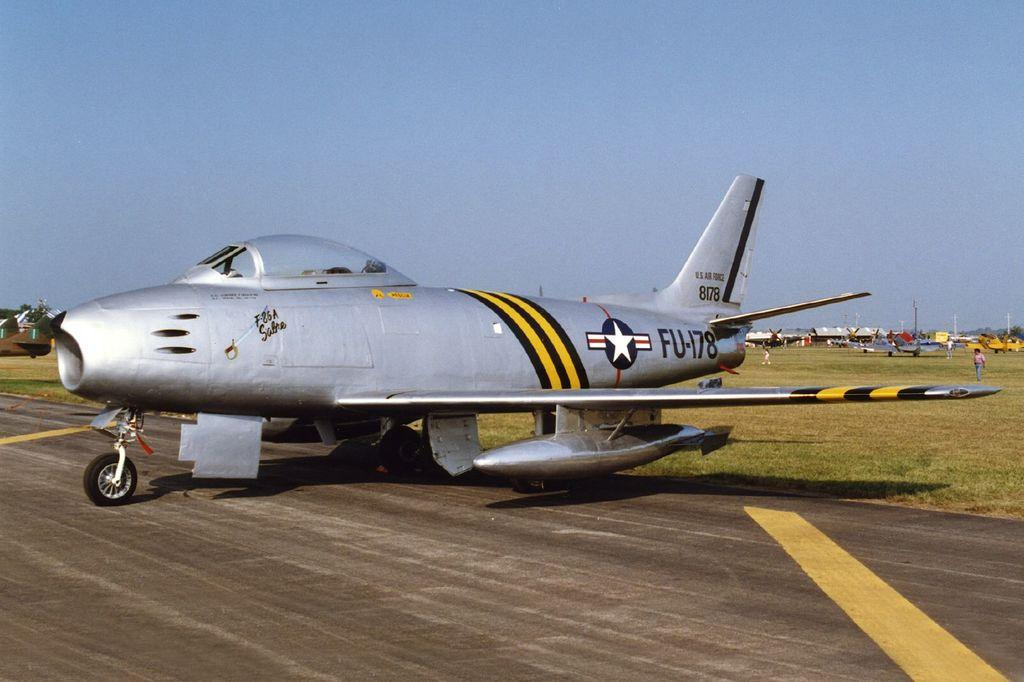<image>
Summarize the visual content of the image. A US Air Force jet sits on the tarmac near a field 